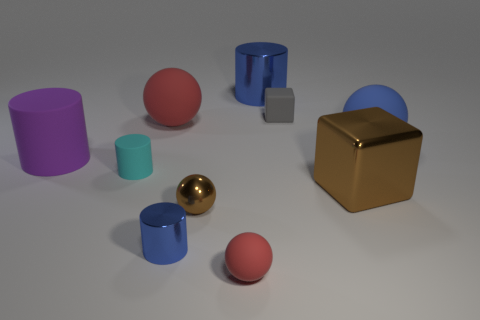How many red spheres must be subtracted to get 1 red spheres? 1 Subtract all small metal cylinders. How many cylinders are left? 3 Subtract all blue spheres. How many spheres are left? 3 Subtract 0 yellow balls. How many objects are left? 10 Subtract all cylinders. How many objects are left? 6 Subtract 2 cylinders. How many cylinders are left? 2 Subtract all cyan spheres. Subtract all brown cubes. How many spheres are left? 4 Subtract all purple cubes. How many gray cylinders are left? 0 Subtract all tiny gray rubber cubes. Subtract all small cyan matte objects. How many objects are left? 8 Add 3 blue rubber balls. How many blue rubber balls are left? 4 